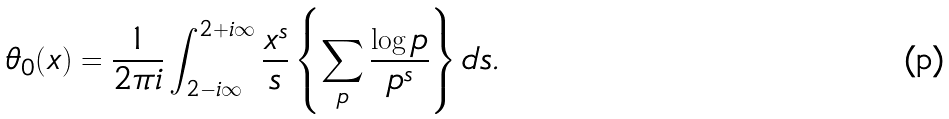Convert formula to latex. <formula><loc_0><loc_0><loc_500><loc_500>\theta _ { 0 } ( x ) = \frac { 1 } { 2 \pi i } \int _ { 2 - i \infty } ^ { 2 + i \infty } \frac { x ^ { s } } { s } \left \{ \sum _ { p } \frac { \log p } { p ^ { s } } \right \} d s .</formula> 